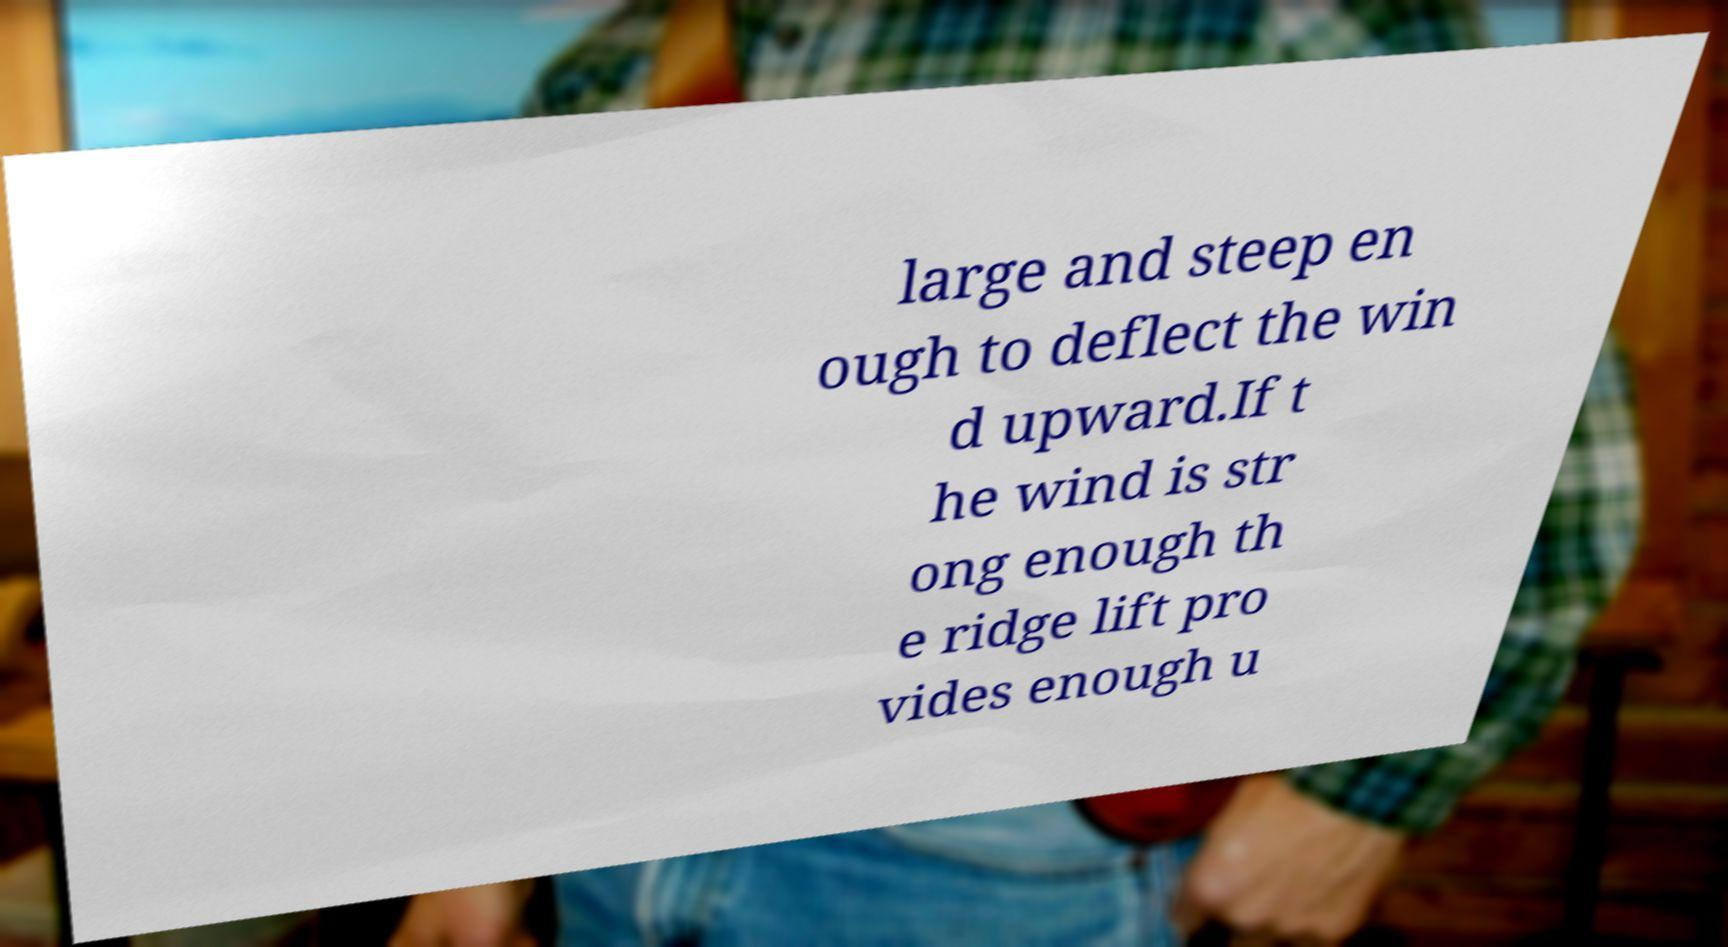Can you accurately transcribe the text from the provided image for me? large and steep en ough to deflect the win d upward.If t he wind is str ong enough th e ridge lift pro vides enough u 